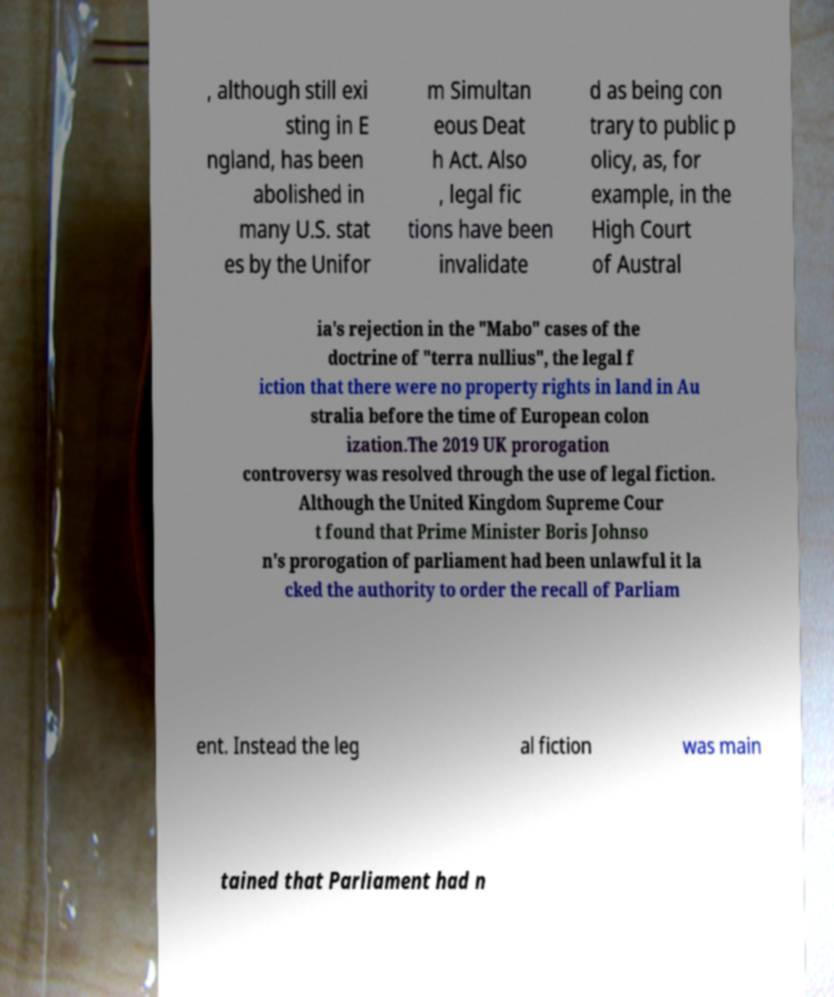Could you assist in decoding the text presented in this image and type it out clearly? , although still exi sting in E ngland, has been abolished in many U.S. stat es by the Unifor m Simultan eous Deat h Act. Also , legal fic tions have been invalidate d as being con trary to public p olicy, as, for example, in the High Court of Austral ia's rejection in the "Mabo" cases of the doctrine of "terra nullius", the legal f iction that there were no property rights in land in Au stralia before the time of European colon ization.The 2019 UK prorogation controversy was resolved through the use of legal fiction. Although the United Kingdom Supreme Cour t found that Prime Minister Boris Johnso n's prorogation of parliament had been unlawful it la cked the authority to order the recall of Parliam ent. Instead the leg al fiction was main tained that Parliament had n 